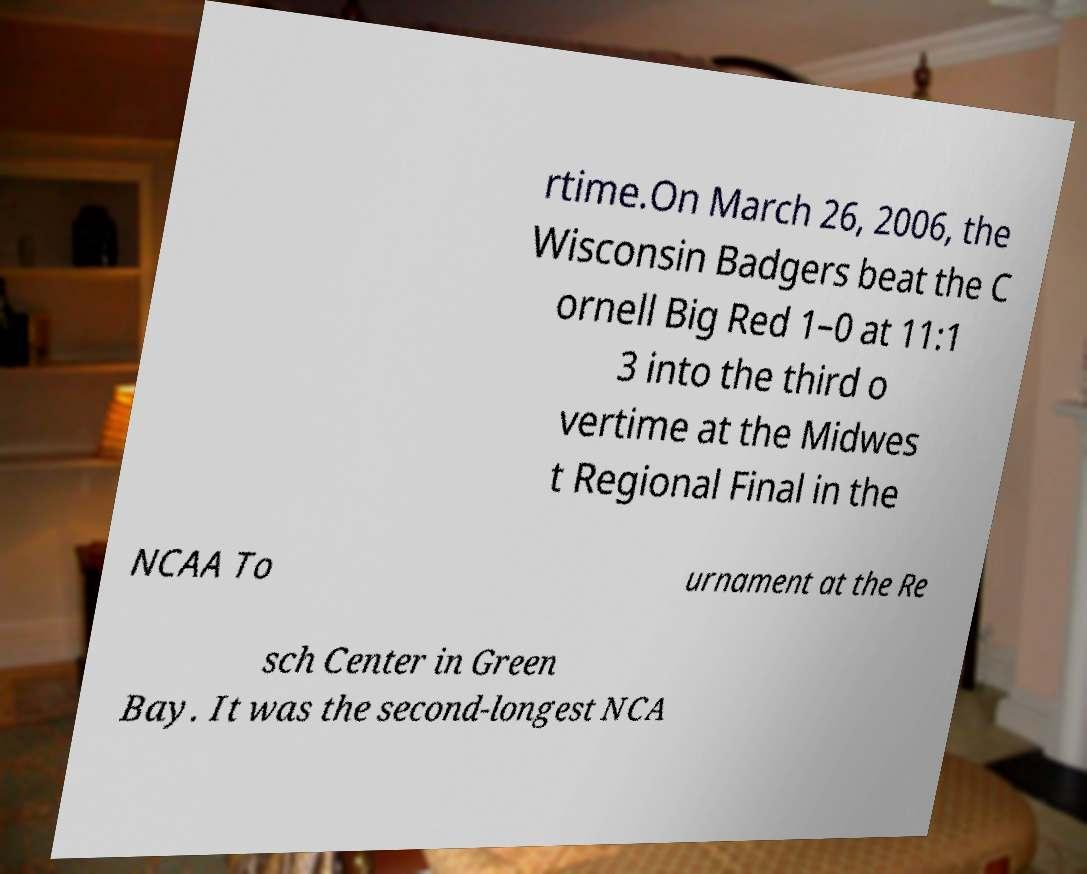Could you assist in decoding the text presented in this image and type it out clearly? rtime.On March 26, 2006, the Wisconsin Badgers beat the C ornell Big Red 1–0 at 11:1 3 into the third o vertime at the Midwes t Regional Final in the NCAA To urnament at the Re sch Center in Green Bay. It was the second-longest NCA 